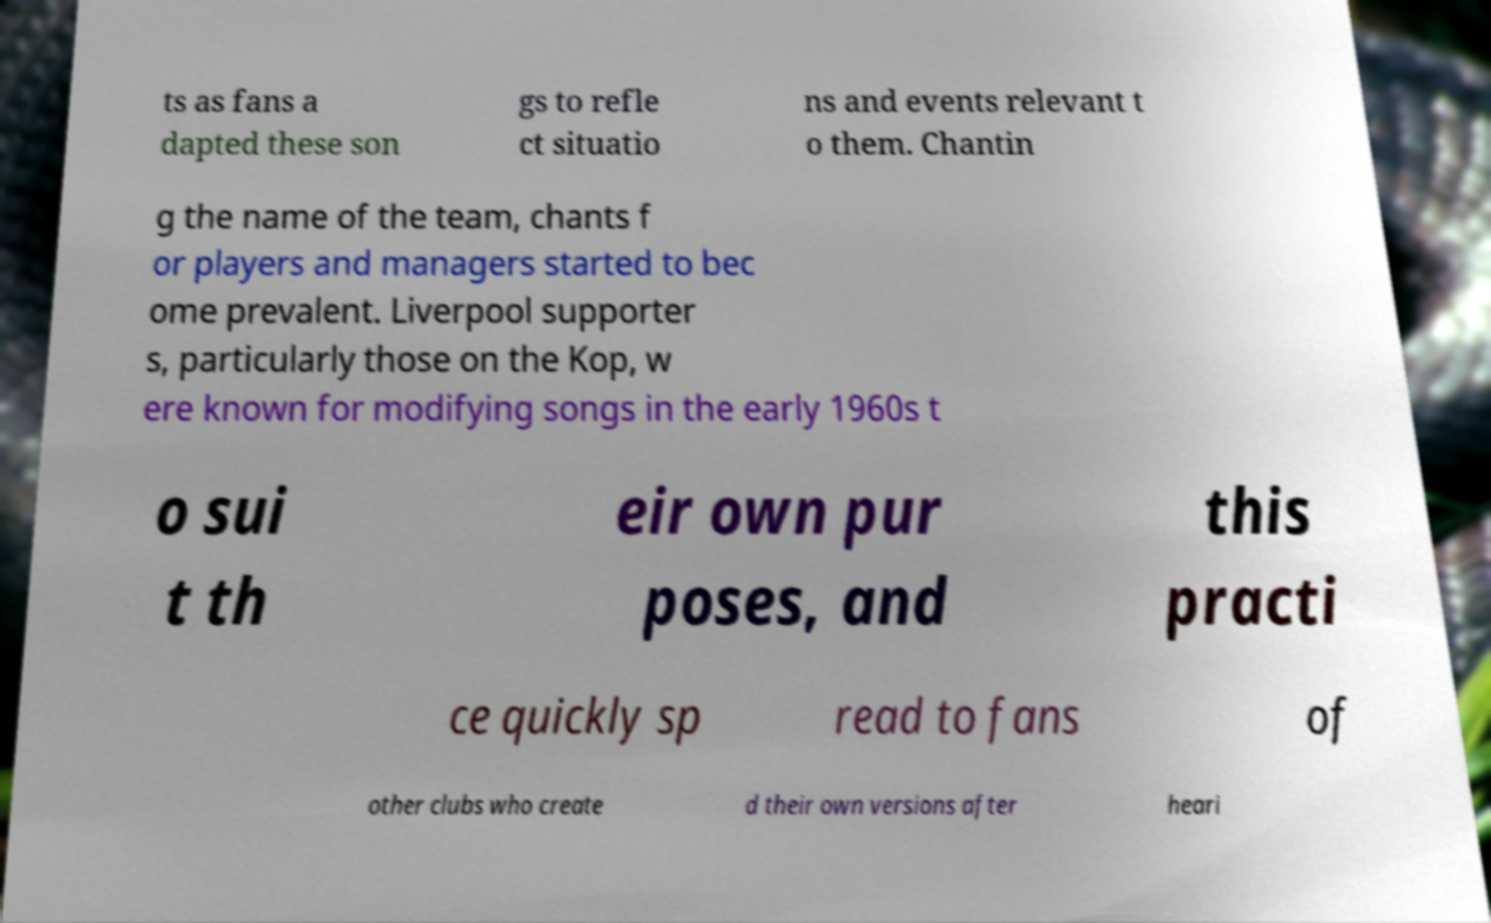Please identify and transcribe the text found in this image. ts as fans a dapted these son gs to refle ct situatio ns and events relevant t o them. Chantin g the name of the team, chants f or players and managers started to bec ome prevalent. Liverpool supporter s, particularly those on the Kop, w ere known for modifying songs in the early 1960s t o sui t th eir own pur poses, and this practi ce quickly sp read to fans of other clubs who create d their own versions after heari 